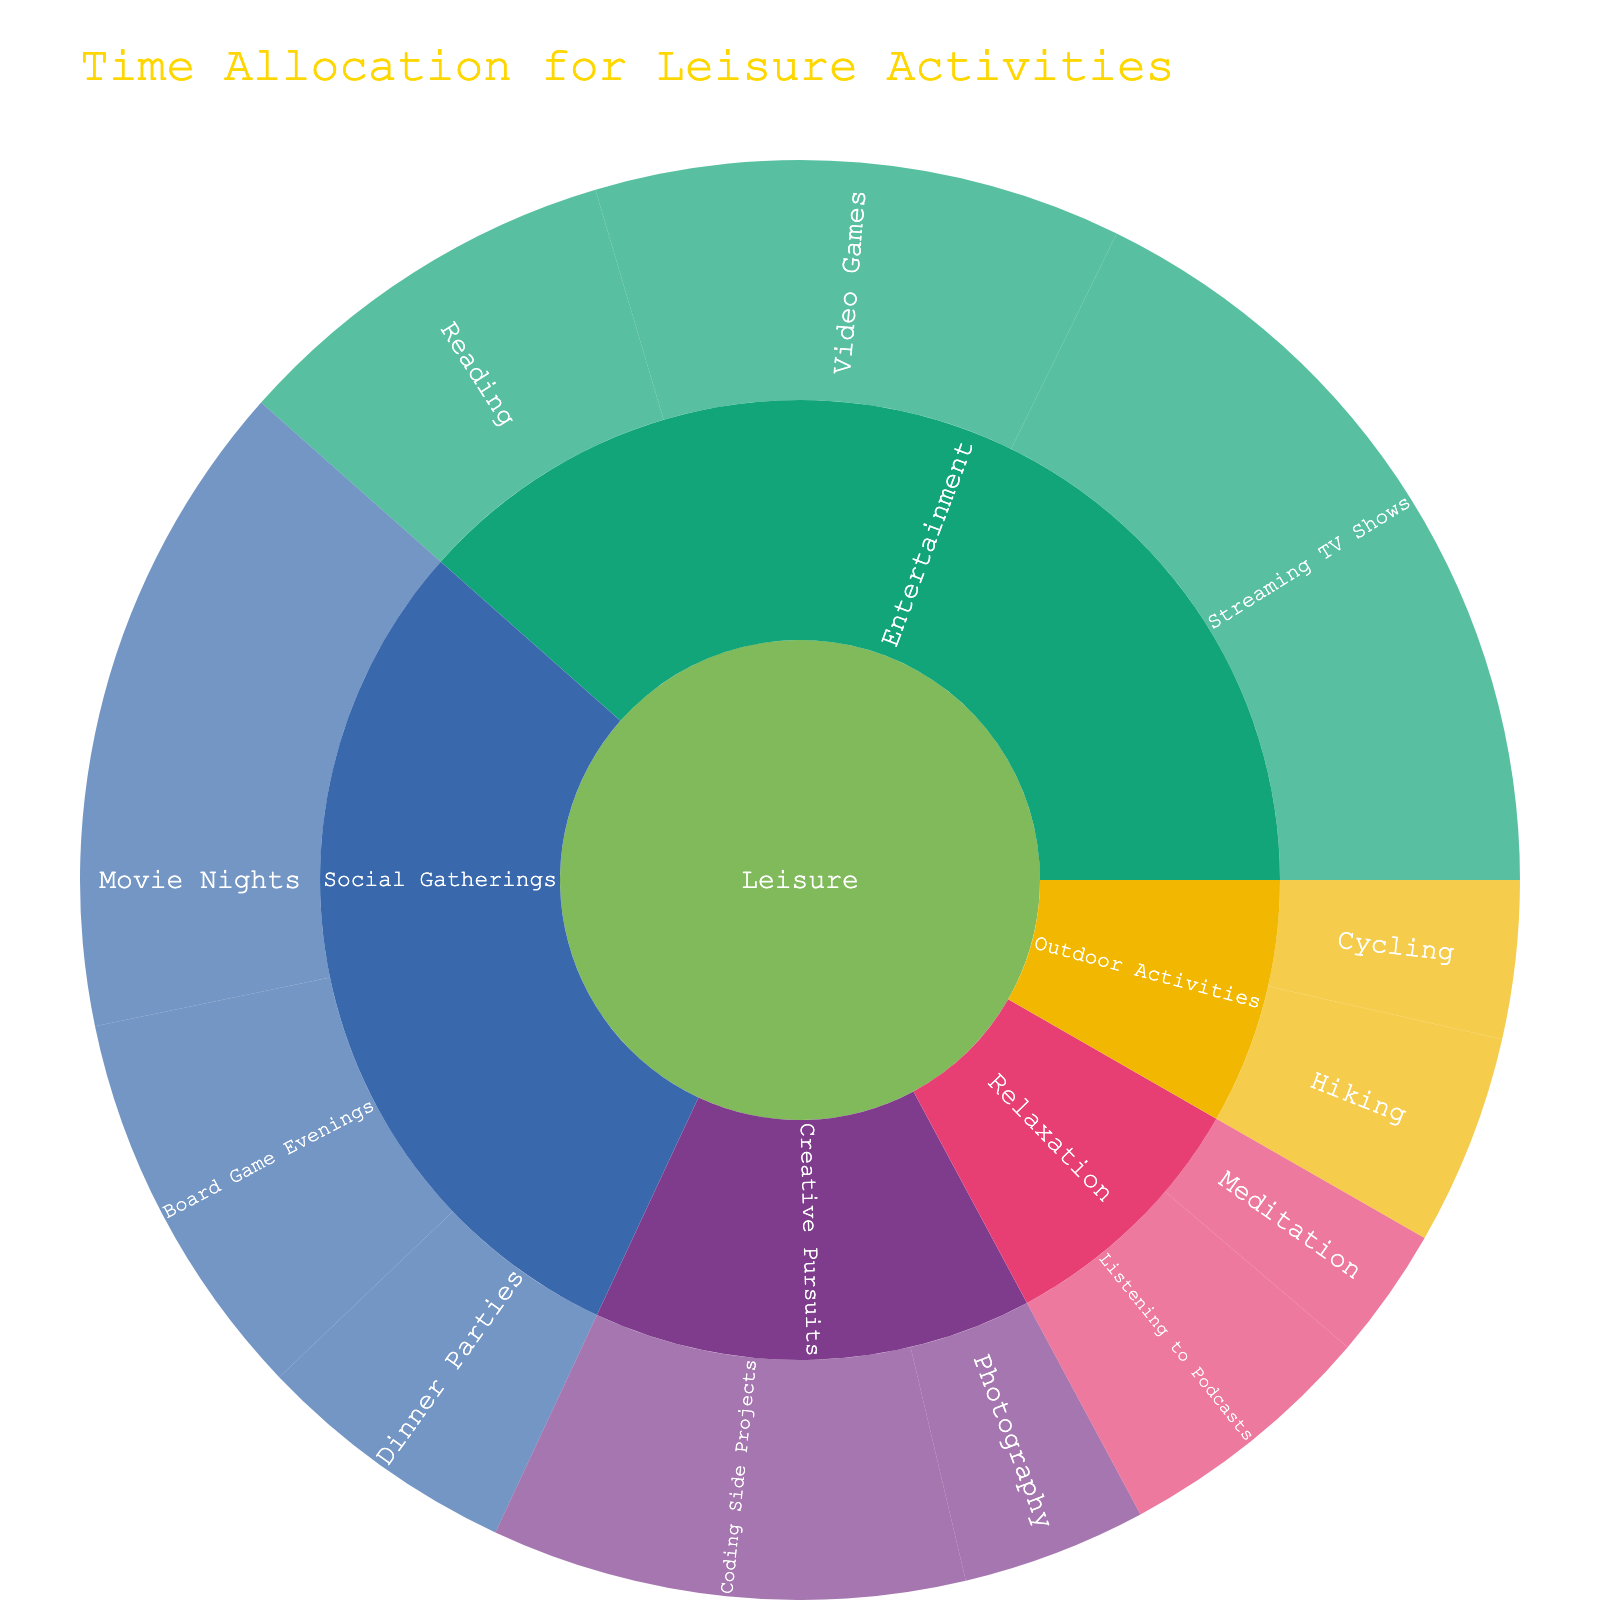What's the title of the Sunburst Plot? The title is displayed at the top of the figure in larger, highlighted font, which helps to understand the overall theme of the chart.
Answer: Time Allocation for Leisure Activities Which activity in the 'Social Gatherings' subcategory has the highest number of hours spent? Look for the 'Social Gatherings' subcategory and identify the activity slice with the largest area.
Answer: Movie Nights What is the total time allocated to 'Social Gatherings'? Sum up the hours for 'Movie Nights', 'Board Game Evenings', and 'Dinner Parties' within the 'Social Gatherings' subcategory.
Answer: 50 How do the hours spent on 'Video Games' compare to 'Coding Side Projects'? Identify the respective slices for 'Video Games' and 'Coding Side Projects' and compare their values.
Answer: Video Games (20) have 2 more hours compared to Coding Side Projects (18) Which subcategory has the smallest allocation of hours? Find the subcategory with the smallest combined area.
Answer: Relaxation Combine the hours spent on 'Hiking' and 'Cycling'. What is the total? Add the hours: Hiking (8) + Cycling (6) = 14.
Answer: 14 Is the time spent on 'Listening to Podcasts' greater than 'Photography'? Compare the hours of these two activities.
Answer: Yes What is the sum of hours for all 'Entertainment' activities? Add hours for 'Video Games', 'Streaming TV Shows', and 'Reading'. Sum: 20 + 30 + 15 = 65.
Answer: 65 Which subcategory within 'Leisure' has the most hours allocated? Identify which subcategory has the most prominent area overall.
Answer: Entertainment How does the allocation of hours for 'Reading' compare to 'Board Game Evenings'? Compare the hour values for these two activities.
Answer: Reading (15) and Board Game Evenings (15) are equal 